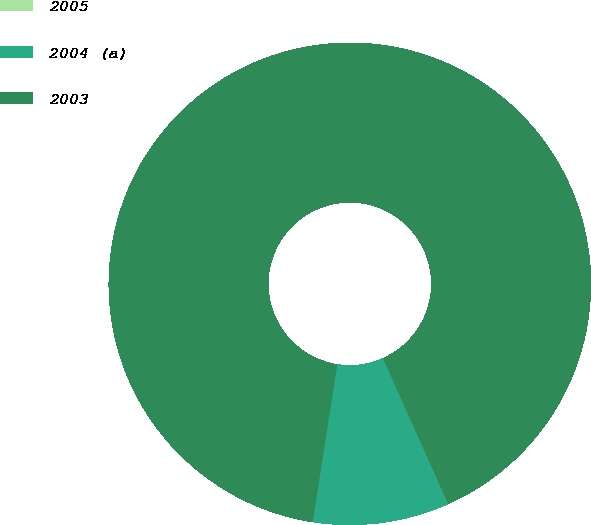<chart> <loc_0><loc_0><loc_500><loc_500><pie_chart><fcel>2005<fcel>2004 (a)<fcel>2003<nl><fcel>0.02%<fcel>9.11%<fcel>90.87%<nl></chart> 